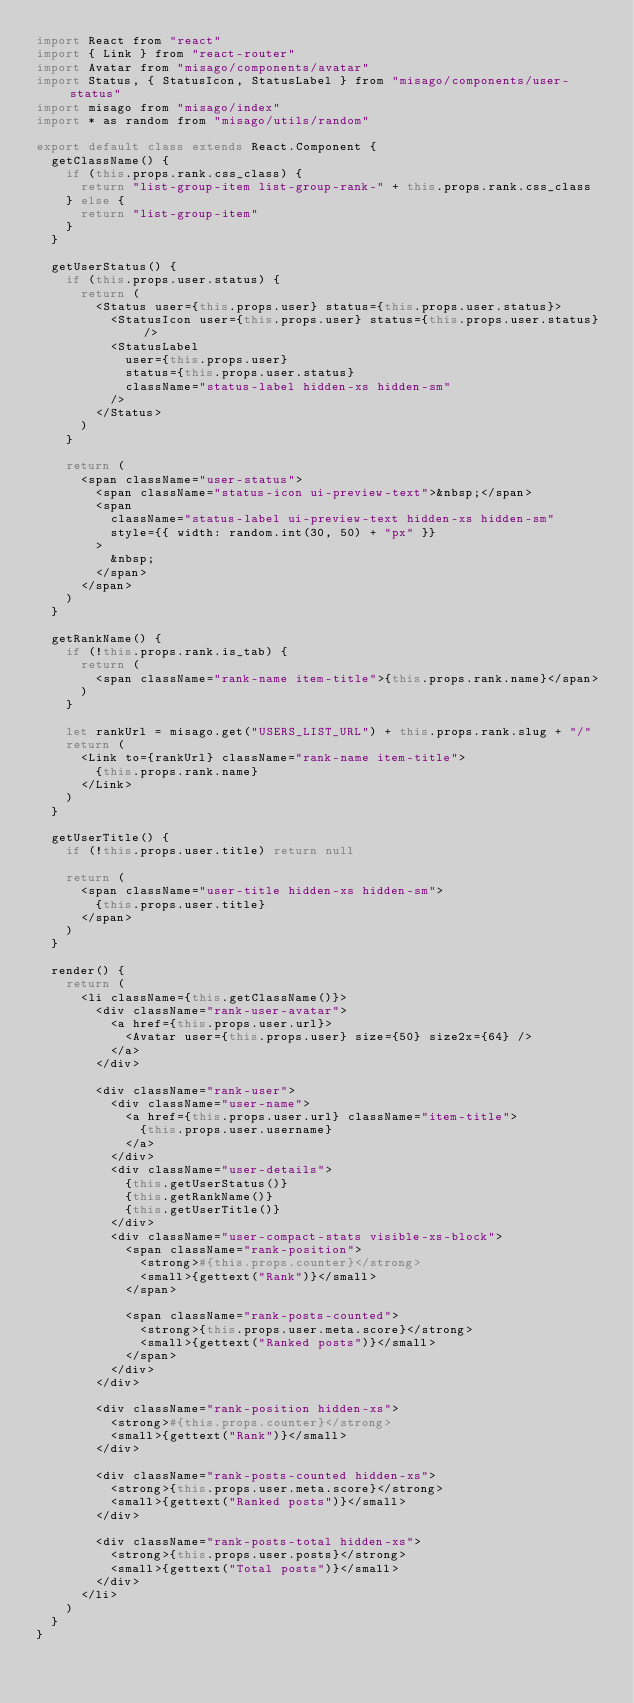Convert code to text. <code><loc_0><loc_0><loc_500><loc_500><_JavaScript_>import React from "react"
import { Link } from "react-router"
import Avatar from "misago/components/avatar"
import Status, { StatusIcon, StatusLabel } from "misago/components/user-status"
import misago from "misago/index"
import * as random from "misago/utils/random"

export default class extends React.Component {
  getClassName() {
    if (this.props.rank.css_class) {
      return "list-group-item list-group-rank-" + this.props.rank.css_class
    } else {
      return "list-group-item"
    }
  }

  getUserStatus() {
    if (this.props.user.status) {
      return (
        <Status user={this.props.user} status={this.props.user.status}>
          <StatusIcon user={this.props.user} status={this.props.user.status} />
          <StatusLabel
            user={this.props.user}
            status={this.props.user.status}
            className="status-label hidden-xs hidden-sm"
          />
        </Status>
      )
    }

    return (
      <span className="user-status">
        <span className="status-icon ui-preview-text">&nbsp;</span>
        <span
          className="status-label ui-preview-text hidden-xs hidden-sm"
          style={{ width: random.int(30, 50) + "px" }}
        >
          &nbsp;
        </span>
      </span>
    )
  }

  getRankName() {
    if (!this.props.rank.is_tab) {
      return (
        <span className="rank-name item-title">{this.props.rank.name}</span>
      )
    }

    let rankUrl = misago.get("USERS_LIST_URL") + this.props.rank.slug + "/"
    return (
      <Link to={rankUrl} className="rank-name item-title">
        {this.props.rank.name}
      </Link>
    )
  }

  getUserTitle() {
    if (!this.props.user.title) return null

    return (
      <span className="user-title hidden-xs hidden-sm">
        {this.props.user.title}
      </span>
    )
  }

  render() {
    return (
      <li className={this.getClassName()}>
        <div className="rank-user-avatar">
          <a href={this.props.user.url}>
            <Avatar user={this.props.user} size={50} size2x={64} />
          </a>
        </div>

        <div className="rank-user">
          <div className="user-name">
            <a href={this.props.user.url} className="item-title">
              {this.props.user.username}
            </a>
          </div>
          <div className="user-details">
            {this.getUserStatus()}
            {this.getRankName()}
            {this.getUserTitle()}
          </div>
          <div className="user-compact-stats visible-xs-block">
            <span className="rank-position">
              <strong>#{this.props.counter}</strong>
              <small>{gettext("Rank")}</small>
            </span>

            <span className="rank-posts-counted">
              <strong>{this.props.user.meta.score}</strong>
              <small>{gettext("Ranked posts")}</small>
            </span>
          </div>
        </div>

        <div className="rank-position hidden-xs">
          <strong>#{this.props.counter}</strong>
          <small>{gettext("Rank")}</small>
        </div>

        <div className="rank-posts-counted hidden-xs">
          <strong>{this.props.user.meta.score}</strong>
          <small>{gettext("Ranked posts")}</small>
        </div>

        <div className="rank-posts-total hidden-xs">
          <strong>{this.props.user.posts}</strong>
          <small>{gettext("Total posts")}</small>
        </div>
      </li>
    )
  }
}
</code> 